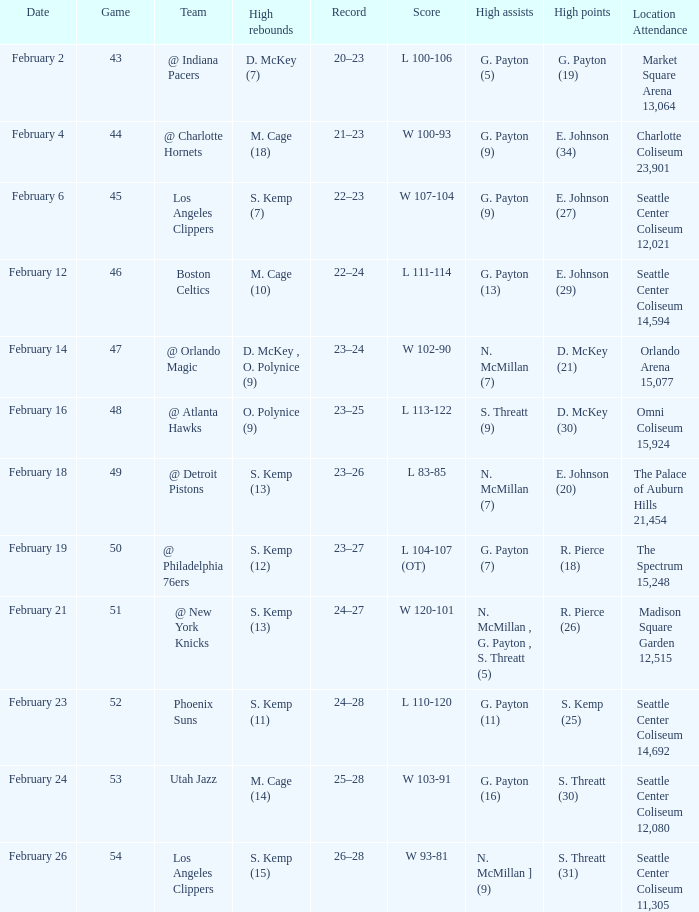What is the record for the Utah Jazz? 25–28. Help me parse the entirety of this table. {'header': ['Date', 'Game', 'Team', 'High rebounds', 'Record', 'Score', 'High assists', 'High points', 'Location Attendance'], 'rows': [['February 2', '43', '@ Indiana Pacers', 'D. McKey (7)', '20–23', 'L 100-106', 'G. Payton (5)', 'G. Payton (19)', 'Market Square Arena 13,064'], ['February 4', '44', '@ Charlotte Hornets', 'M. Cage (18)', '21–23', 'W 100-93', 'G. Payton (9)', 'E. Johnson (34)', 'Charlotte Coliseum 23,901'], ['February 6', '45', 'Los Angeles Clippers', 'S. Kemp (7)', '22–23', 'W 107-104', 'G. Payton (9)', 'E. Johnson (27)', 'Seattle Center Coliseum 12,021'], ['February 12', '46', 'Boston Celtics', 'M. Cage (10)', '22–24', 'L 111-114', 'G. Payton (13)', 'E. Johnson (29)', 'Seattle Center Coliseum 14,594'], ['February 14', '47', '@ Orlando Magic', 'D. McKey , O. Polynice (9)', '23–24', 'W 102-90', 'N. McMillan (7)', 'D. McKey (21)', 'Orlando Arena 15,077'], ['February 16', '48', '@ Atlanta Hawks', 'O. Polynice (9)', '23–25', 'L 113-122', 'S. Threatt (9)', 'D. McKey (30)', 'Omni Coliseum 15,924'], ['February 18', '49', '@ Detroit Pistons', 'S. Kemp (13)', '23–26', 'L 83-85', 'N. McMillan (7)', 'E. Johnson (20)', 'The Palace of Auburn Hills 21,454'], ['February 19', '50', '@ Philadelphia 76ers', 'S. Kemp (12)', '23–27', 'L 104-107 (OT)', 'G. Payton (7)', 'R. Pierce (18)', 'The Spectrum 15,248'], ['February 21', '51', '@ New York Knicks', 'S. Kemp (13)', '24–27', 'W 120-101', 'N. McMillan , G. Payton , S. Threatt (5)', 'R. Pierce (26)', 'Madison Square Garden 12,515'], ['February 23', '52', 'Phoenix Suns', 'S. Kemp (11)', '24–28', 'L 110-120', 'G. Payton (11)', 'S. Kemp (25)', 'Seattle Center Coliseum 14,692'], ['February 24', '53', 'Utah Jazz', 'M. Cage (14)', '25–28', 'W 103-91', 'G. Payton (16)', 'S. Threatt (30)', 'Seattle Center Coliseum 12,080'], ['February 26', '54', 'Los Angeles Clippers', 'S. Kemp (15)', '26–28', 'W 93-81', 'N. McMillan ] (9)', 'S. Threatt (31)', 'Seattle Center Coliseum 11,305']]} 